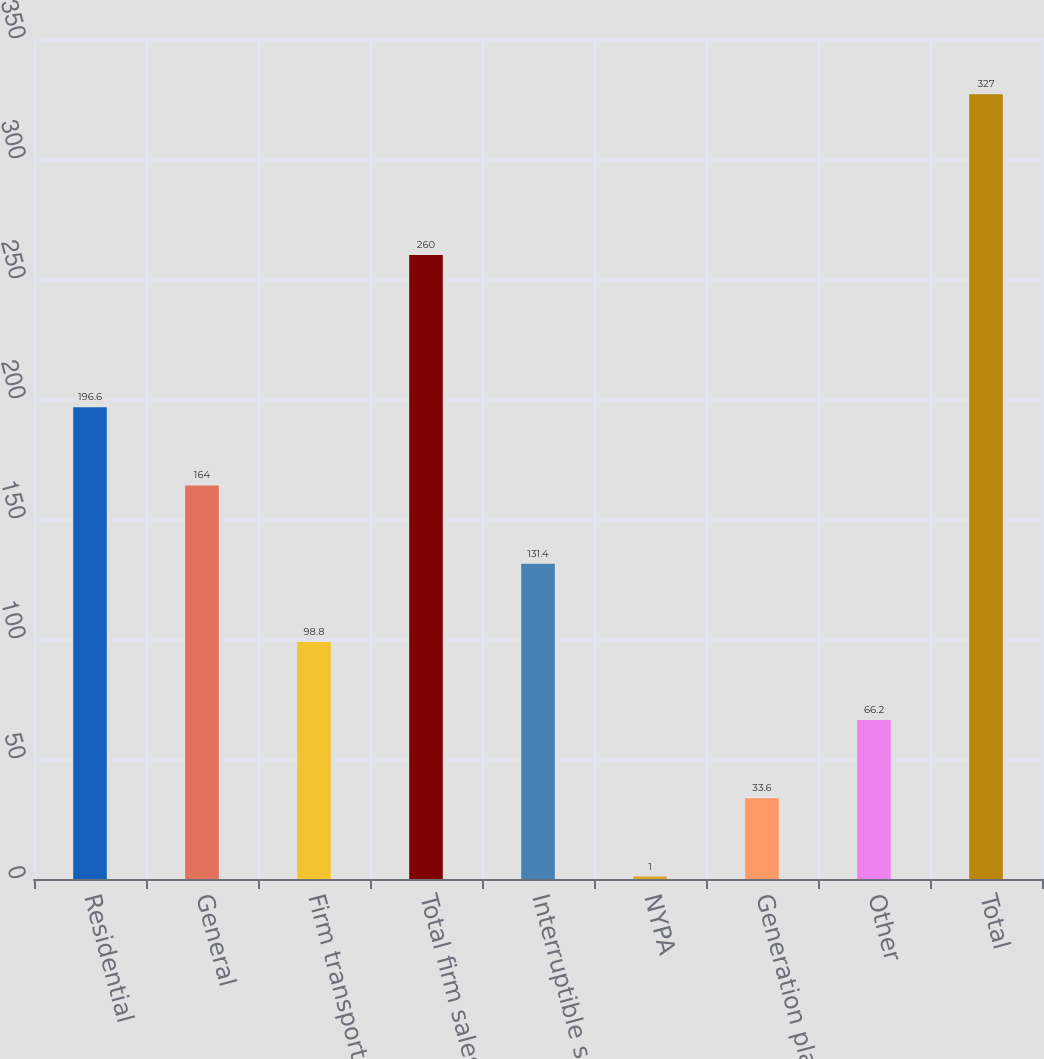<chart> <loc_0><loc_0><loc_500><loc_500><bar_chart><fcel>Residential<fcel>General<fcel>Firm transportation<fcel>Total firm sales and<fcel>Interruptible sales<fcel>NYPA<fcel>Generation plants<fcel>Other<fcel>Total<nl><fcel>196.6<fcel>164<fcel>98.8<fcel>260<fcel>131.4<fcel>1<fcel>33.6<fcel>66.2<fcel>327<nl></chart> 